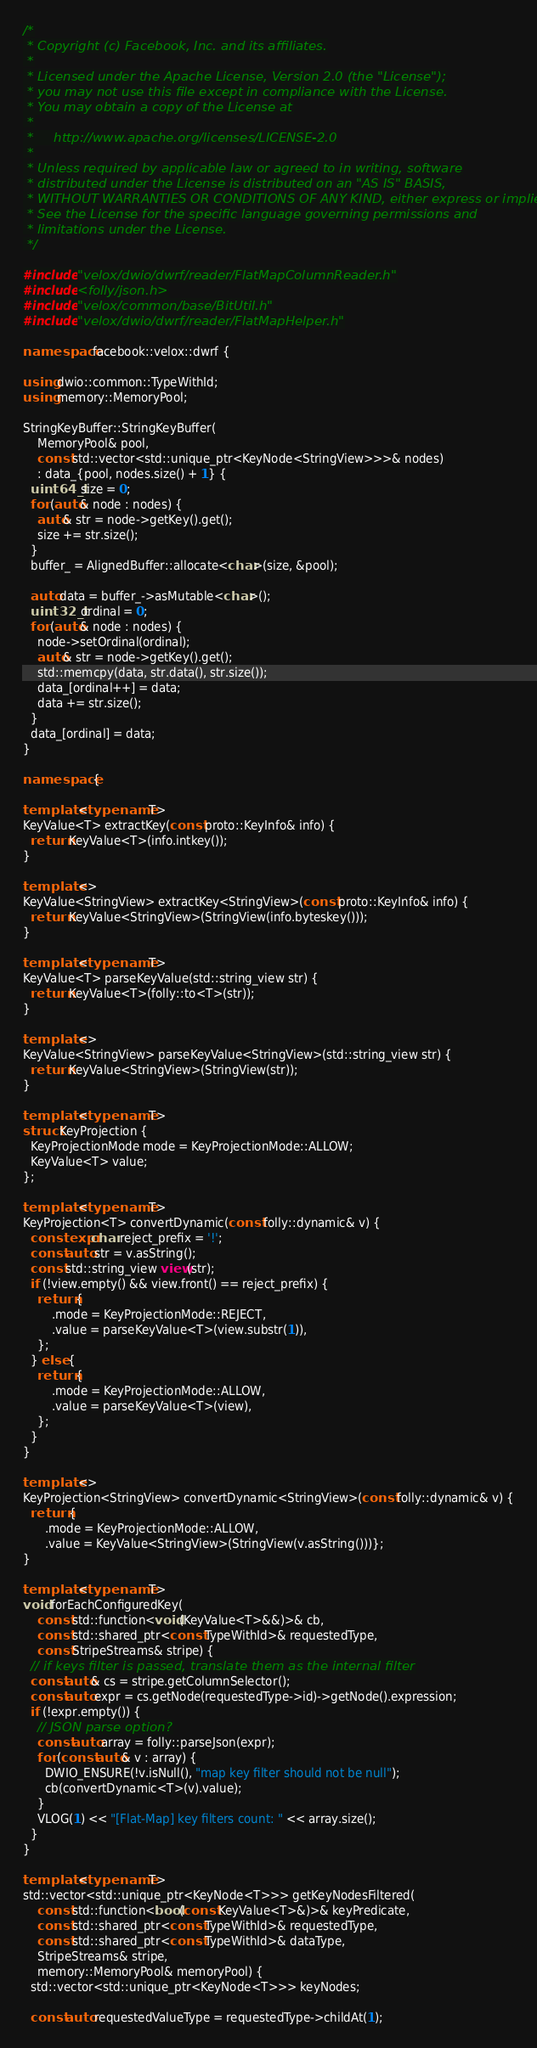<code> <loc_0><loc_0><loc_500><loc_500><_C++_>/*
 * Copyright (c) Facebook, Inc. and its affiliates.
 *
 * Licensed under the Apache License, Version 2.0 (the "License");
 * you may not use this file except in compliance with the License.
 * You may obtain a copy of the License at
 *
 *     http://www.apache.org/licenses/LICENSE-2.0
 *
 * Unless required by applicable law or agreed to in writing, software
 * distributed under the License is distributed on an "AS IS" BASIS,
 * WITHOUT WARRANTIES OR CONDITIONS OF ANY KIND, either express or implied.
 * See the License for the specific language governing permissions and
 * limitations under the License.
 */

#include "velox/dwio/dwrf/reader/FlatMapColumnReader.h"
#include <folly/json.h>
#include "velox/common/base/BitUtil.h"
#include "velox/dwio/dwrf/reader/FlatMapHelper.h"

namespace facebook::velox::dwrf {

using dwio::common::TypeWithId;
using memory::MemoryPool;

StringKeyBuffer::StringKeyBuffer(
    MemoryPool& pool,
    const std::vector<std::unique_ptr<KeyNode<StringView>>>& nodes)
    : data_{pool, nodes.size() + 1} {
  uint64_t size = 0;
  for (auto& node : nodes) {
    auto& str = node->getKey().get();
    size += str.size();
  }
  buffer_ = AlignedBuffer::allocate<char>(size, &pool);

  auto data = buffer_->asMutable<char>();
  uint32_t ordinal = 0;
  for (auto& node : nodes) {
    node->setOrdinal(ordinal);
    auto& str = node->getKey().get();
    std::memcpy(data, str.data(), str.size());
    data_[ordinal++] = data;
    data += str.size();
  }
  data_[ordinal] = data;
}

namespace {

template <typename T>
KeyValue<T> extractKey(const proto::KeyInfo& info) {
  return KeyValue<T>(info.intkey());
}

template <>
KeyValue<StringView> extractKey<StringView>(const proto::KeyInfo& info) {
  return KeyValue<StringView>(StringView(info.byteskey()));
}

template <typename T>
KeyValue<T> parseKeyValue(std::string_view str) {
  return KeyValue<T>(folly::to<T>(str));
}

template <>
KeyValue<StringView> parseKeyValue<StringView>(std::string_view str) {
  return KeyValue<StringView>(StringView(str));
}

template <typename T>
struct KeyProjection {
  KeyProjectionMode mode = KeyProjectionMode::ALLOW;
  KeyValue<T> value;
};

template <typename T>
KeyProjection<T> convertDynamic(const folly::dynamic& v) {
  constexpr char reject_prefix = '!';
  const auto str = v.asString();
  const std::string_view view(str);
  if (!view.empty() && view.front() == reject_prefix) {
    return {
        .mode = KeyProjectionMode::REJECT,
        .value = parseKeyValue<T>(view.substr(1)),
    };
  } else {
    return {
        .mode = KeyProjectionMode::ALLOW,
        .value = parseKeyValue<T>(view),
    };
  }
}

template <>
KeyProjection<StringView> convertDynamic<StringView>(const folly::dynamic& v) {
  return {
      .mode = KeyProjectionMode::ALLOW,
      .value = KeyValue<StringView>(StringView(v.asString()))};
}

template <typename T>
void forEachConfiguredKey(
    const std::function<void(KeyValue<T>&&)>& cb,
    const std::shared_ptr<const TypeWithId>& requestedType,
    const StripeStreams& stripe) {
  // if keys filter is passed, translate them as the internal filter
  const auto& cs = stripe.getColumnSelector();
  const auto expr = cs.getNode(requestedType->id)->getNode().expression;
  if (!expr.empty()) {
    // JSON parse option?
    const auto array = folly::parseJson(expr);
    for (const auto& v : array) {
      DWIO_ENSURE(!v.isNull(), "map key filter should not be null");
      cb(convertDynamic<T>(v).value);
    }
    VLOG(1) << "[Flat-Map] key filters count: " << array.size();
  }
}

template <typename T>
std::vector<std::unique_ptr<KeyNode<T>>> getKeyNodesFiltered(
    const std::function<bool(const KeyValue<T>&)>& keyPredicate,
    const std::shared_ptr<const TypeWithId>& requestedType,
    const std::shared_ptr<const TypeWithId>& dataType,
    StripeStreams& stripe,
    memory::MemoryPool& memoryPool) {
  std::vector<std::unique_ptr<KeyNode<T>>> keyNodes;

  const auto requestedValueType = requestedType->childAt(1);</code> 